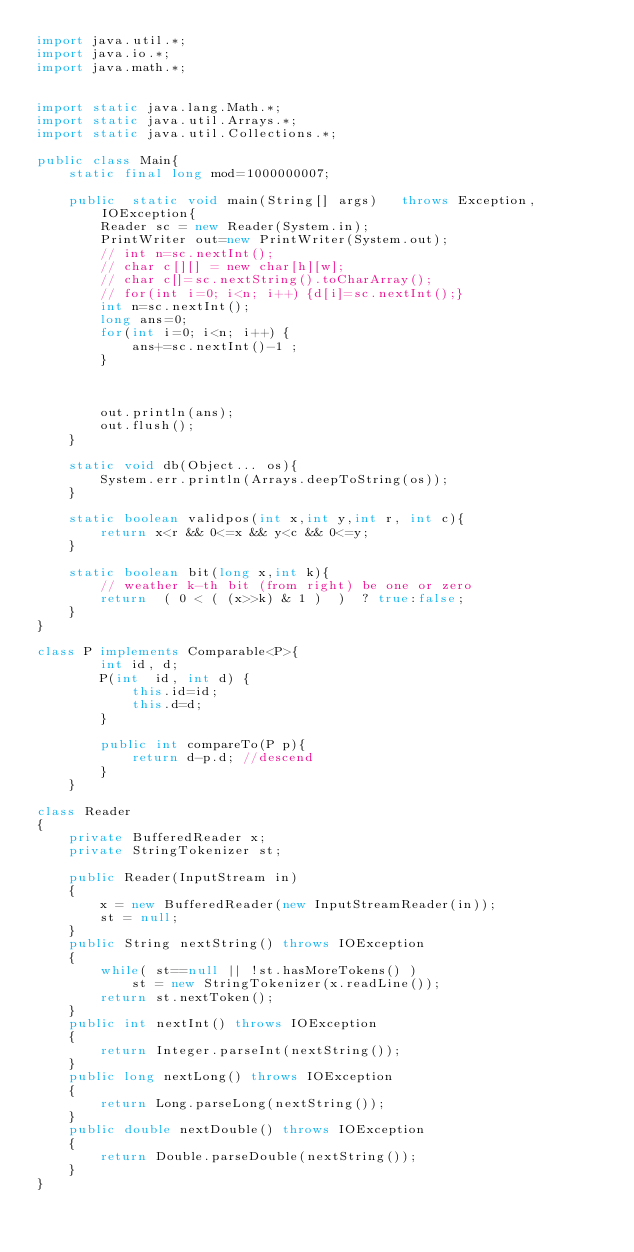<code> <loc_0><loc_0><loc_500><loc_500><_Java_>import java.util.*;
import java.io.*;
import java.math.*;
 
 
import static java.lang.Math.*;
import static java.util.Arrays.*;
import static java.util.Collections.*;
 
public class Main{
    static final long mod=1000000007;
    
    public  static void main(String[] args)   throws Exception, IOException{
        Reader sc = new Reader(System.in);
        PrintWriter out=new PrintWriter(System.out);
        // int n=sc.nextInt();
        // char c[][] = new char[h][w];
        // char c[]=sc.nextString().toCharArray();
        // for(int i=0; i<n; i++) {d[i]=sc.nextInt();}
        int n=sc.nextInt();
        long ans=0;
        for(int i=0; i<n; i++) {
            ans+=sc.nextInt()-1 ;
        }

       

        out.println(ans);
        out.flush();
    }
    
    static void db(Object... os){
        System.err.println(Arrays.deepToString(os));
    }
     
    static boolean validpos(int x,int y,int r, int c){
        return x<r && 0<=x && y<c && 0<=y;
    }
    
    static boolean bit(long x,int k){
        // weather k-th bit (from right) be one or zero
        return  ( 0 < ( (x>>k) & 1 )  )  ? true:false;
    }    
}

class P implements Comparable<P>{
        int id, d;
        P(int  id, int d) {
            this.id=id;
            this.d=d;
        } 
          
        public int compareTo(P p){
            return d-p.d; //descend
        }
    }

class Reader
{ 
    private BufferedReader x;
    private StringTokenizer st;
    
    public Reader(InputStream in)
    {
        x = new BufferedReader(new InputStreamReader(in));
        st = null;
    }
    public String nextString() throws IOException
    {
        while( st==null || !st.hasMoreTokens() )
            st = new StringTokenizer(x.readLine());
        return st.nextToken();
    }
    public int nextInt() throws IOException
    {
        return Integer.parseInt(nextString());
    }
    public long nextLong() throws IOException
    {
        return Long.parseLong(nextString());
    }
    public double nextDouble() throws IOException
    {
        return Double.parseDouble(nextString());
    }
}</code> 